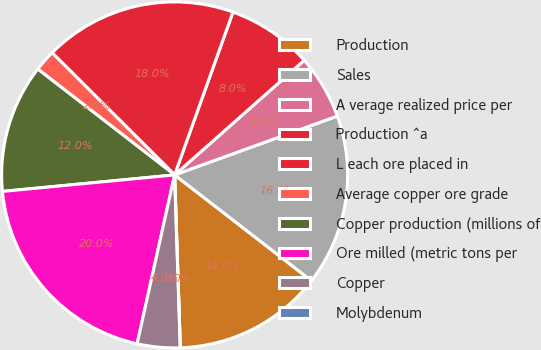Convert chart to OTSL. <chart><loc_0><loc_0><loc_500><loc_500><pie_chart><fcel>Production<fcel>Sales<fcel>A verage realized price per<fcel>Production ^a<fcel>L each ore placed in<fcel>Average copper ore grade<fcel>Copper production (millions of<fcel>Ore milled (metric tons per<fcel>Copper<fcel>Molybdenum<nl><fcel>14.0%<fcel>16.0%<fcel>6.0%<fcel>8.0%<fcel>18.0%<fcel>2.0%<fcel>12.0%<fcel>20.0%<fcel>4.0%<fcel>0.0%<nl></chart> 